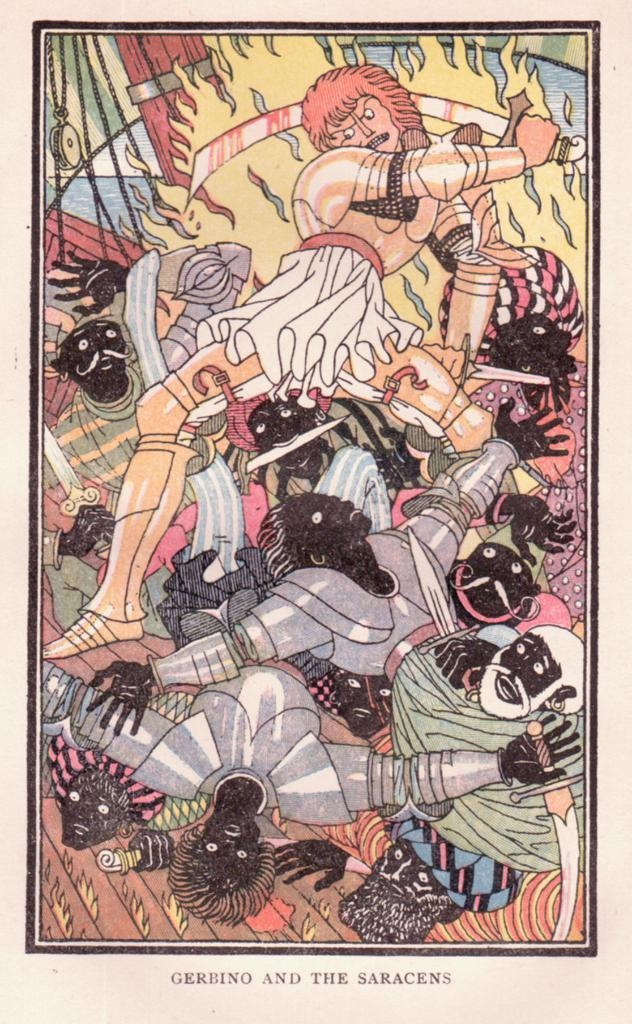What type of images are present in the picture? There are cartoon pictures in the image. Can you describe the color scheme of the cartoon pictures? The cartoon pictures are in multiple colors. Is there any text present in the image? Yes, there is text written on the image. What type of harmony is being played by the dog in the image? There is no dog present in the image, and therefore no such activity can be observed. 